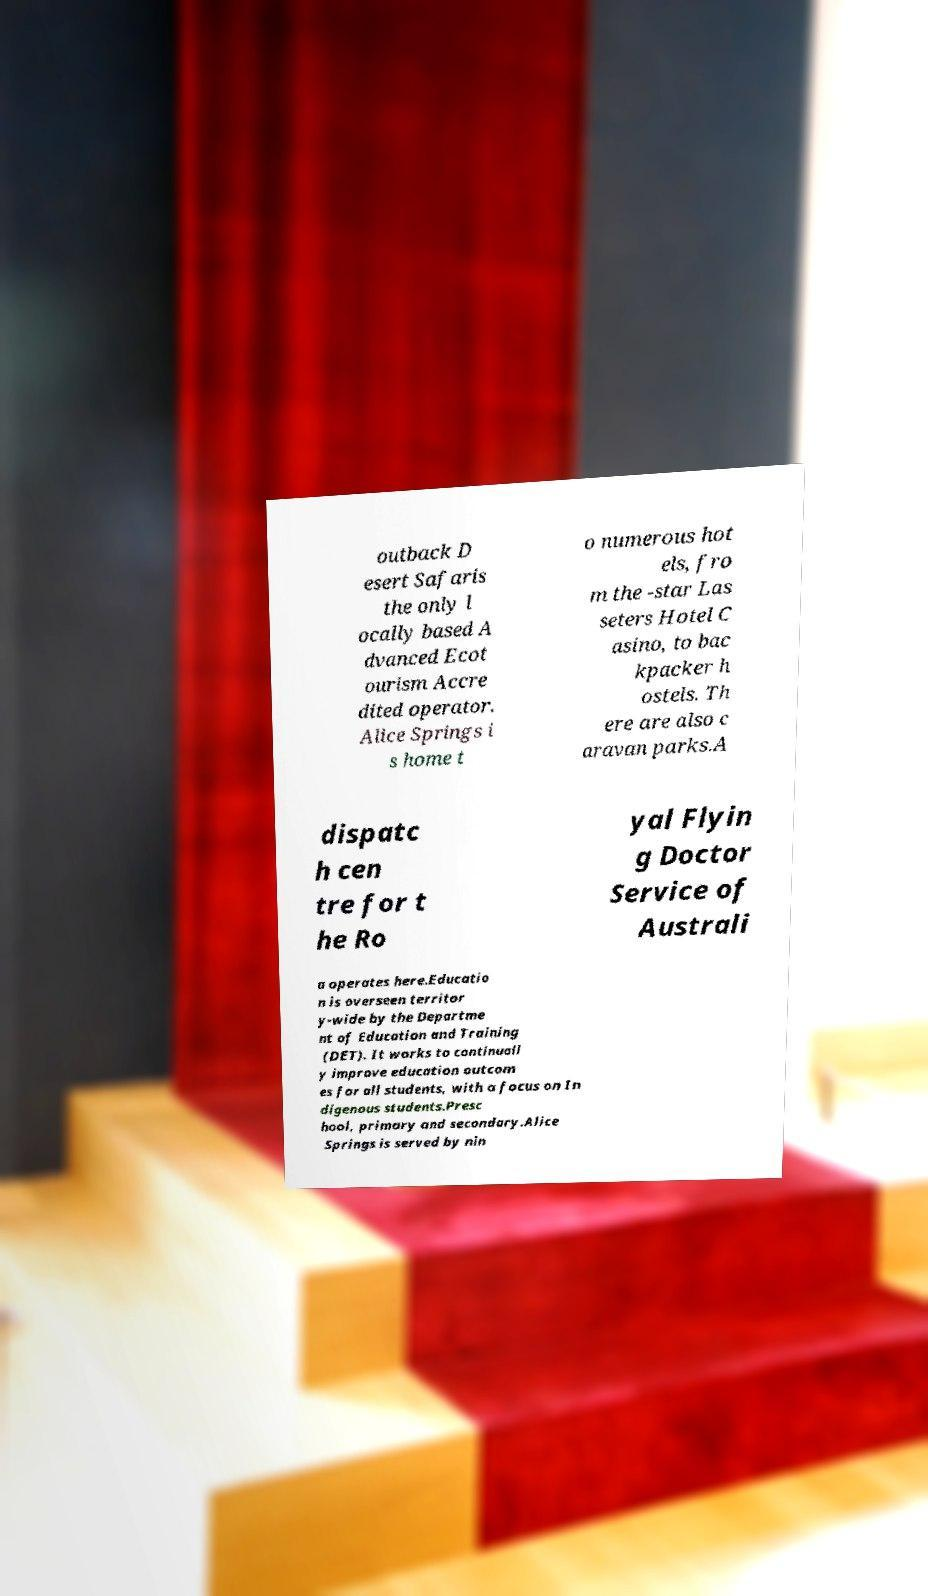Can you accurately transcribe the text from the provided image for me? outback D esert Safaris the only l ocally based A dvanced Ecot ourism Accre dited operator. Alice Springs i s home t o numerous hot els, fro m the -star Las seters Hotel C asino, to bac kpacker h ostels. Th ere are also c aravan parks.A dispatc h cen tre for t he Ro yal Flyin g Doctor Service of Australi a operates here.Educatio n is overseen territor y-wide by the Departme nt of Education and Training (DET). It works to continuall y improve education outcom es for all students, with a focus on In digenous students.Presc hool, primary and secondary.Alice Springs is served by nin 